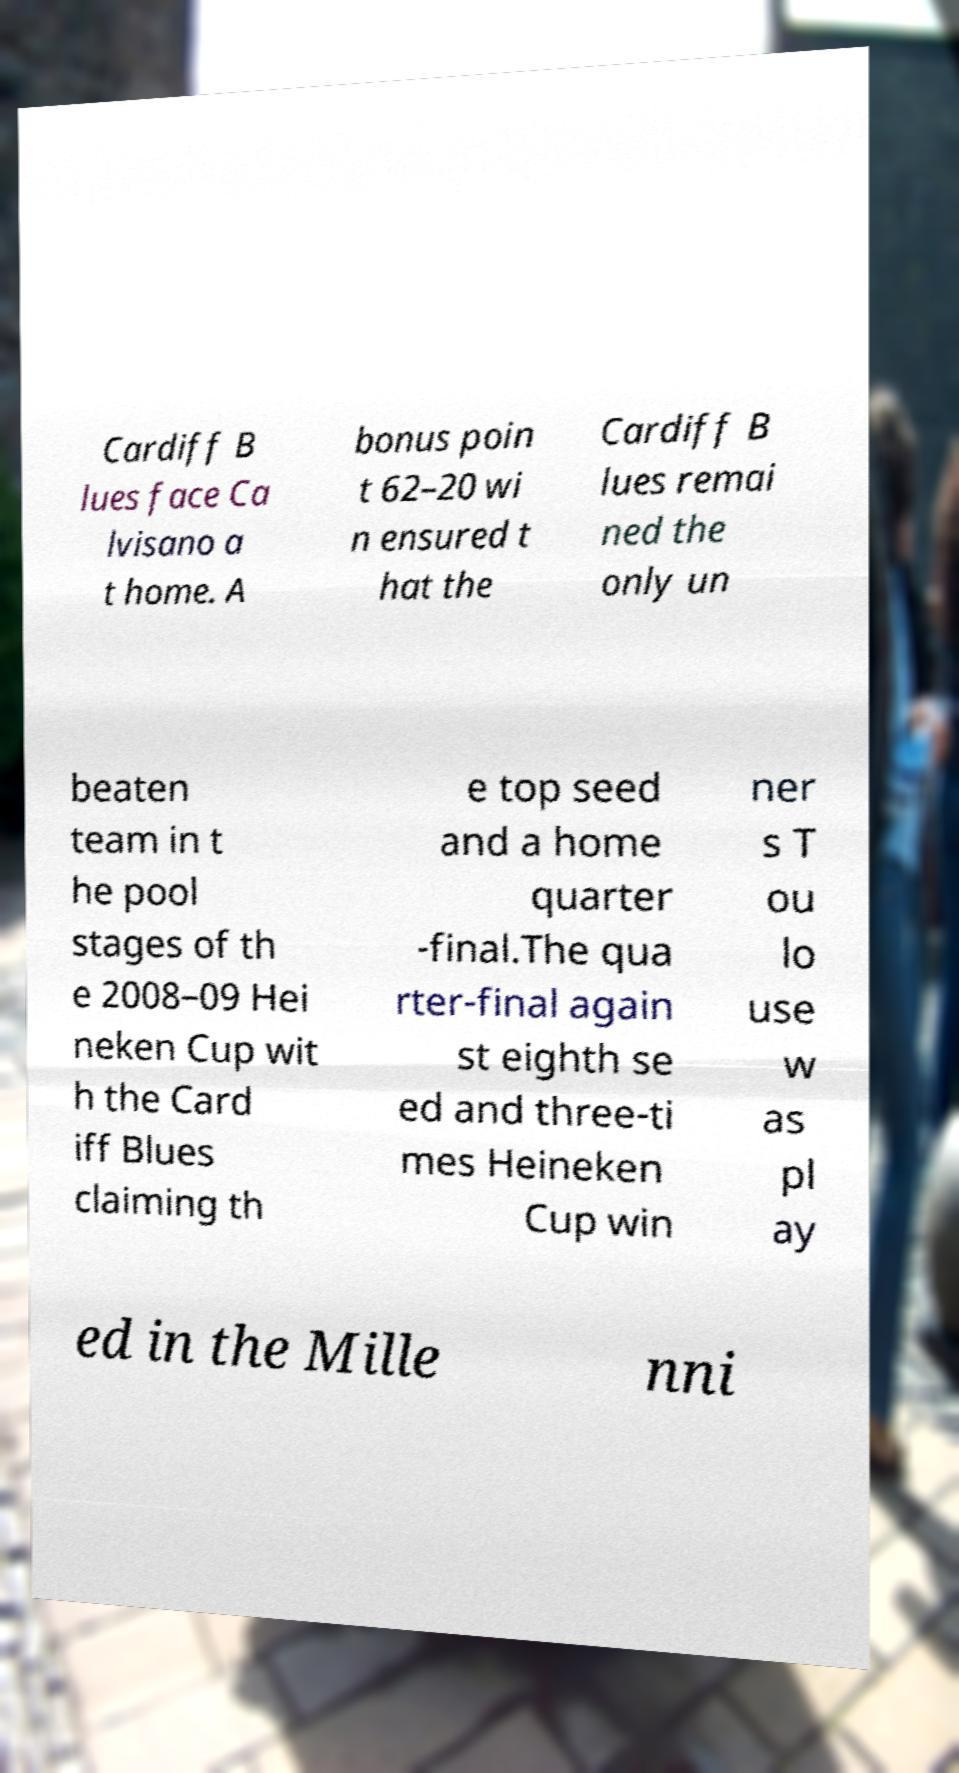Please identify and transcribe the text found in this image. Cardiff B lues face Ca lvisano a t home. A bonus poin t 62–20 wi n ensured t hat the Cardiff B lues remai ned the only un beaten team in t he pool stages of th e 2008–09 Hei neken Cup wit h the Card iff Blues claiming th e top seed and a home quarter -final.The qua rter-final again st eighth se ed and three-ti mes Heineken Cup win ner s T ou lo use w as pl ay ed in the Mille nni 